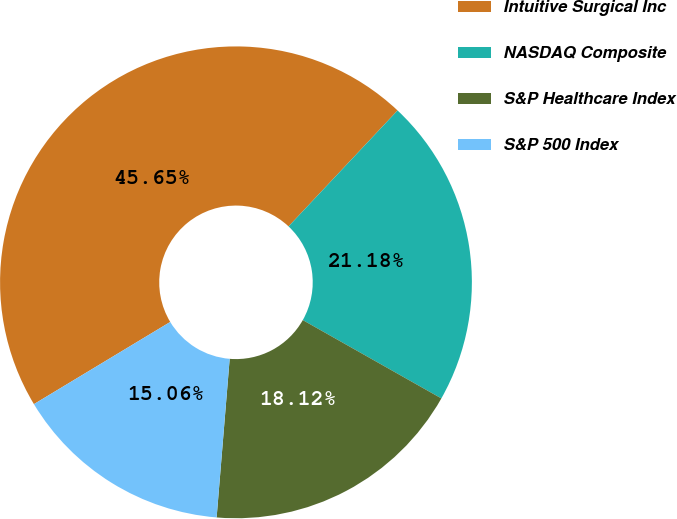Convert chart to OTSL. <chart><loc_0><loc_0><loc_500><loc_500><pie_chart><fcel>Intuitive Surgical Inc<fcel>NASDAQ Composite<fcel>S&P Healthcare Index<fcel>S&P 500 Index<nl><fcel>45.65%<fcel>21.18%<fcel>18.12%<fcel>15.06%<nl></chart> 